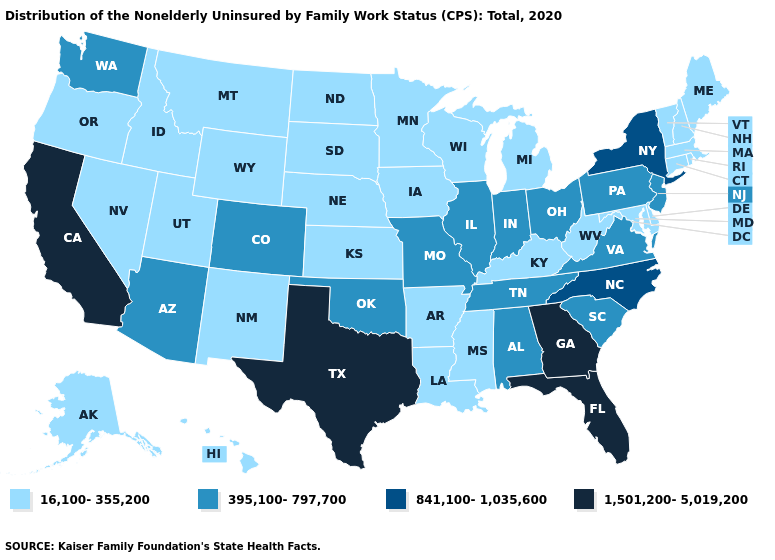Among the states that border Nevada , does California have the highest value?
Answer briefly. Yes. Name the states that have a value in the range 395,100-797,700?
Keep it brief. Alabama, Arizona, Colorado, Illinois, Indiana, Missouri, New Jersey, Ohio, Oklahoma, Pennsylvania, South Carolina, Tennessee, Virginia, Washington. Does Maine have a lower value than South Carolina?
Give a very brief answer. Yes. What is the value of New Mexico?
Concise answer only. 16,100-355,200. Among the states that border Wyoming , which have the lowest value?
Keep it brief. Idaho, Montana, Nebraska, South Dakota, Utah. Name the states that have a value in the range 1,501,200-5,019,200?
Give a very brief answer. California, Florida, Georgia, Texas. Name the states that have a value in the range 395,100-797,700?
Give a very brief answer. Alabama, Arizona, Colorado, Illinois, Indiana, Missouri, New Jersey, Ohio, Oklahoma, Pennsylvania, South Carolina, Tennessee, Virginia, Washington. How many symbols are there in the legend?
Be succinct. 4. Name the states that have a value in the range 841,100-1,035,600?
Be succinct. New York, North Carolina. What is the highest value in the South ?
Quick response, please. 1,501,200-5,019,200. Name the states that have a value in the range 16,100-355,200?
Answer briefly. Alaska, Arkansas, Connecticut, Delaware, Hawaii, Idaho, Iowa, Kansas, Kentucky, Louisiana, Maine, Maryland, Massachusetts, Michigan, Minnesota, Mississippi, Montana, Nebraska, Nevada, New Hampshire, New Mexico, North Dakota, Oregon, Rhode Island, South Dakota, Utah, Vermont, West Virginia, Wisconsin, Wyoming. Name the states that have a value in the range 841,100-1,035,600?
Write a very short answer. New York, North Carolina. What is the value of Hawaii?
Concise answer only. 16,100-355,200. What is the value of New York?
Give a very brief answer. 841,100-1,035,600. Name the states that have a value in the range 395,100-797,700?
Give a very brief answer. Alabama, Arizona, Colorado, Illinois, Indiana, Missouri, New Jersey, Ohio, Oklahoma, Pennsylvania, South Carolina, Tennessee, Virginia, Washington. 